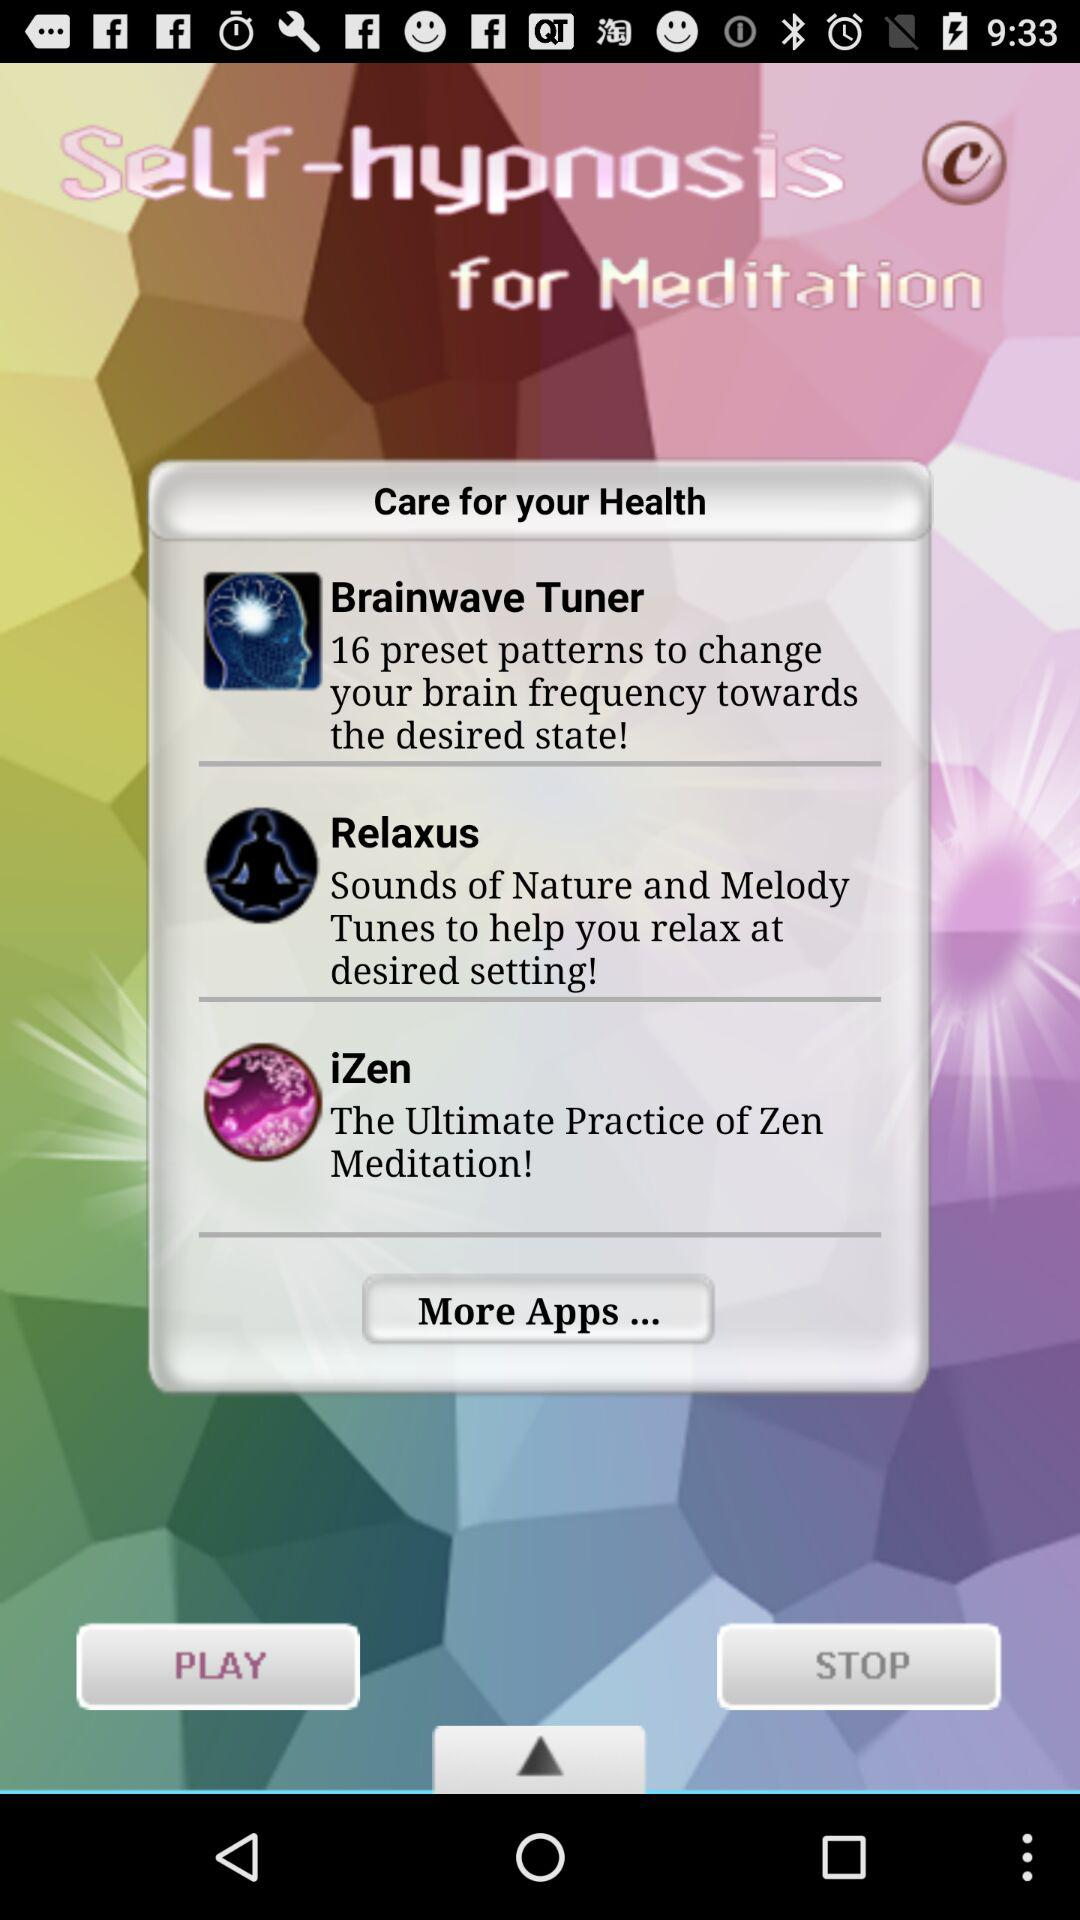What are the different applications for health? The different applications for health are "Brainwave Tuner", "Relaxus" and "iZen". 